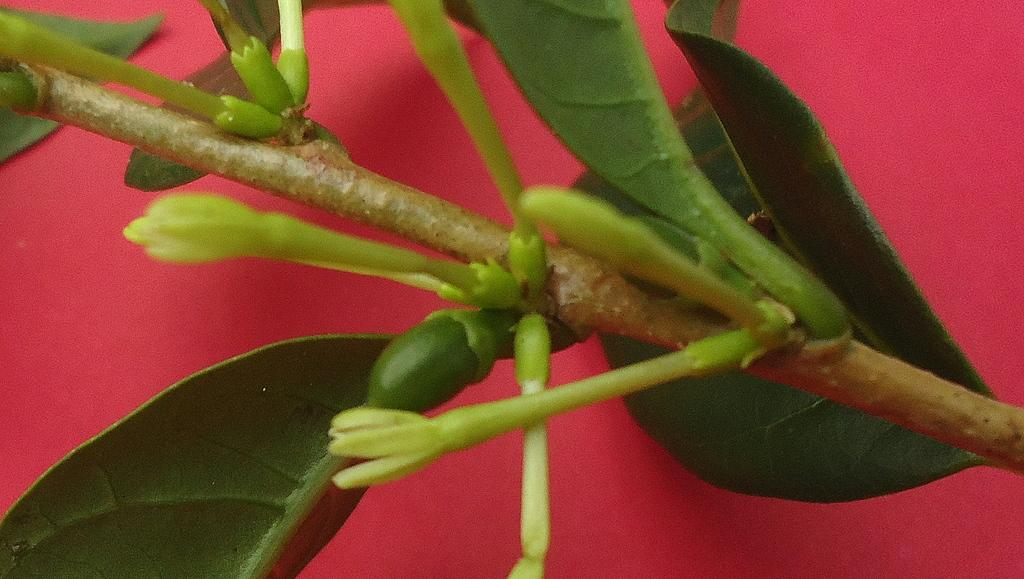What is the main subject of the picture? The main subject of the picture is a stem of a plant. What can be observed on the stem? The stem has buds and leaves. What is the color of the surface on which the plant is placed? The plant is placed on a red-colored surface. What type of toy is your mom holding in the picture? There is no person, including your mom, or any toy present in the image. The image only features a stem of a plant with buds and leaves on a red-colored surface. 